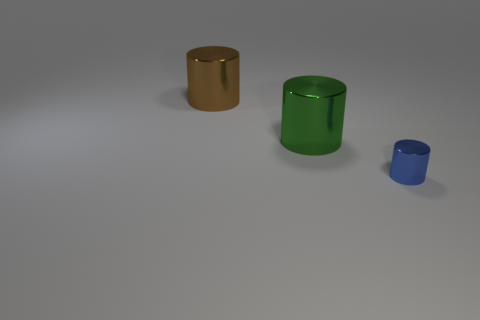Subtract all brown cylinders. How many cylinders are left? 2 Add 3 blue objects. How many objects exist? 6 Subtract 1 cylinders. How many cylinders are left? 2 Add 3 big brown shiny cylinders. How many big brown shiny cylinders are left? 4 Add 1 small cylinders. How many small cylinders exist? 2 Subtract 0 gray blocks. How many objects are left? 3 Subtract all small gray matte cylinders. Subtract all brown cylinders. How many objects are left? 2 